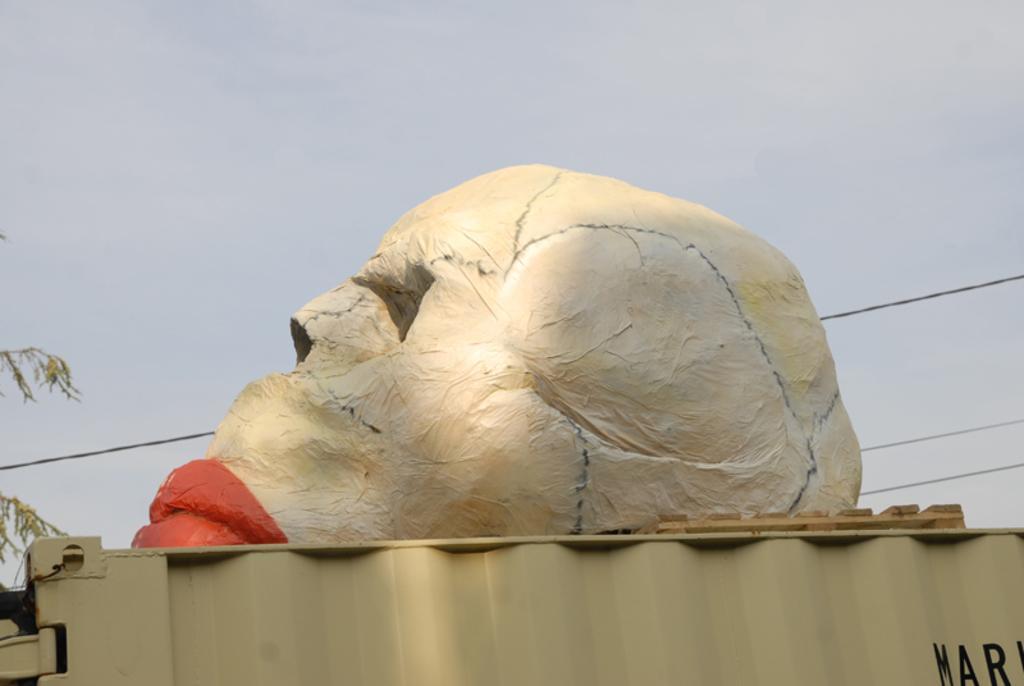Can you describe this image briefly? It looks like a statue in the shape of a human skull. At the bottom it is an iron sheet, at the top it is the sky. 